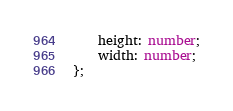Convert code to text. <code><loc_0><loc_0><loc_500><loc_500><_TypeScript_>    height: number;
    width: number;
};
</code> 